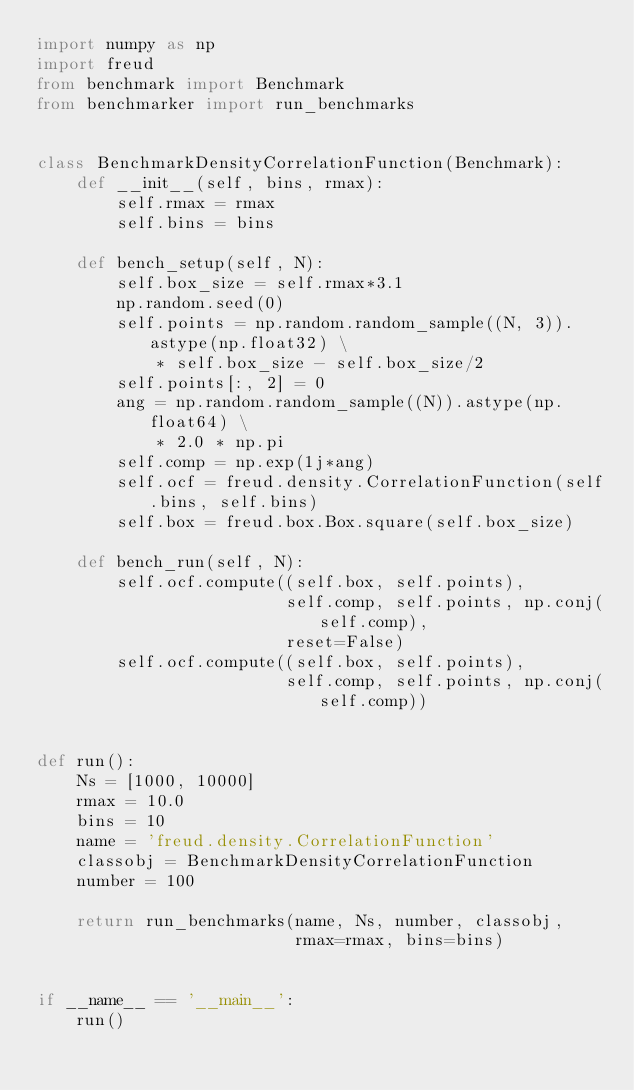<code> <loc_0><loc_0><loc_500><loc_500><_Python_>import numpy as np
import freud
from benchmark import Benchmark
from benchmarker import run_benchmarks


class BenchmarkDensityCorrelationFunction(Benchmark):
    def __init__(self, bins, rmax):
        self.rmax = rmax
        self.bins = bins

    def bench_setup(self, N):
        self.box_size = self.rmax*3.1
        np.random.seed(0)
        self.points = np.random.random_sample((N, 3)).astype(np.float32) \
            * self.box_size - self.box_size/2
        self.points[:, 2] = 0
        ang = np.random.random_sample((N)).astype(np.float64) \
            * 2.0 * np.pi
        self.comp = np.exp(1j*ang)
        self.ocf = freud.density.CorrelationFunction(self.bins, self.bins)
        self.box = freud.box.Box.square(self.box_size)

    def bench_run(self, N):
        self.ocf.compute((self.box, self.points),
                         self.comp, self.points, np.conj(self.comp),
                         reset=False)
        self.ocf.compute((self.box, self.points),
                         self.comp, self.points, np.conj(self.comp))


def run():
    Ns = [1000, 10000]
    rmax = 10.0
    bins = 10
    name = 'freud.density.CorrelationFunction'
    classobj = BenchmarkDensityCorrelationFunction
    number = 100

    return run_benchmarks(name, Ns, number, classobj,
                          rmax=rmax, bins=bins)


if __name__ == '__main__':
    run()
</code> 